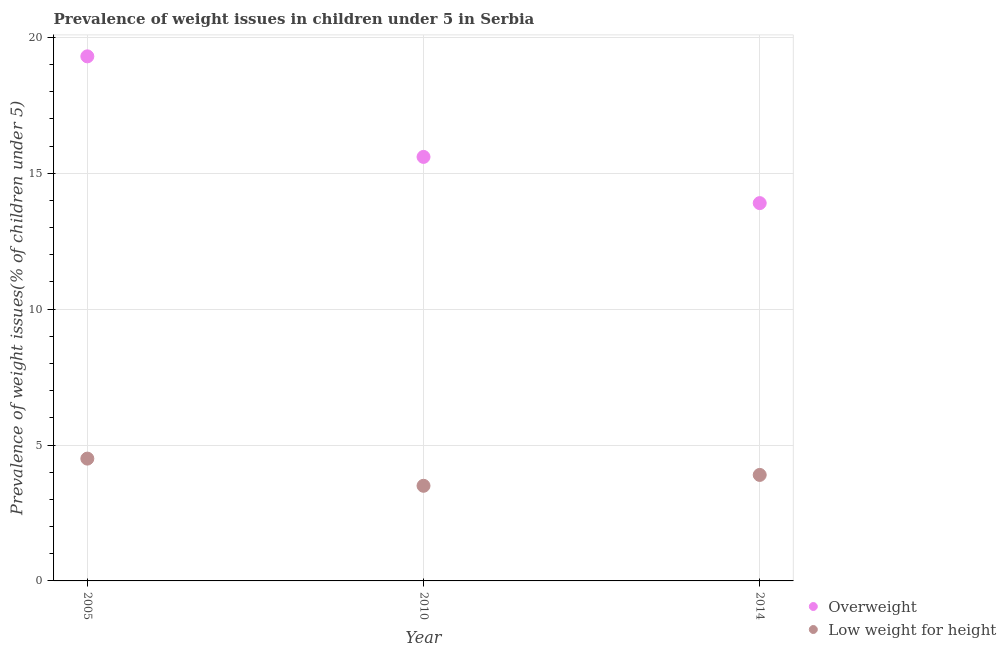How many different coloured dotlines are there?
Offer a terse response. 2. Is the number of dotlines equal to the number of legend labels?
Provide a short and direct response. Yes. Across all years, what is the maximum percentage of overweight children?
Offer a terse response. 19.3. In which year was the percentage of underweight children maximum?
Your answer should be very brief. 2005. What is the total percentage of underweight children in the graph?
Your answer should be compact. 11.9. What is the difference between the percentage of overweight children in 2005 and that in 2014?
Give a very brief answer. 5.4. What is the difference between the percentage of overweight children in 2010 and the percentage of underweight children in 2014?
Offer a very short reply. 11.7. What is the average percentage of underweight children per year?
Offer a terse response. 3.97. In the year 2010, what is the difference between the percentage of overweight children and percentage of underweight children?
Provide a short and direct response. 12.1. In how many years, is the percentage of overweight children greater than 9 %?
Offer a terse response. 3. What is the ratio of the percentage of overweight children in 2005 to that in 2014?
Make the answer very short. 1.39. Is the difference between the percentage of underweight children in 2005 and 2010 greater than the difference between the percentage of overweight children in 2005 and 2010?
Offer a very short reply. No. What is the difference between the highest and the second highest percentage of underweight children?
Provide a short and direct response. 0.6. Does the percentage of underweight children monotonically increase over the years?
Provide a succinct answer. No. Is the percentage of underweight children strictly greater than the percentage of overweight children over the years?
Your answer should be very brief. No. How many dotlines are there?
Keep it short and to the point. 2. How many years are there in the graph?
Ensure brevity in your answer.  3. Are the values on the major ticks of Y-axis written in scientific E-notation?
Keep it short and to the point. No. Does the graph contain any zero values?
Your answer should be compact. No. Where does the legend appear in the graph?
Your response must be concise. Bottom right. What is the title of the graph?
Ensure brevity in your answer.  Prevalence of weight issues in children under 5 in Serbia. What is the label or title of the Y-axis?
Keep it short and to the point. Prevalence of weight issues(% of children under 5). What is the Prevalence of weight issues(% of children under 5) in Overweight in 2005?
Offer a terse response. 19.3. What is the Prevalence of weight issues(% of children under 5) of Low weight for height in 2005?
Offer a very short reply. 4.5. What is the Prevalence of weight issues(% of children under 5) in Overweight in 2010?
Offer a terse response. 15.6. What is the Prevalence of weight issues(% of children under 5) of Overweight in 2014?
Give a very brief answer. 13.9. What is the Prevalence of weight issues(% of children under 5) in Low weight for height in 2014?
Make the answer very short. 3.9. Across all years, what is the maximum Prevalence of weight issues(% of children under 5) in Overweight?
Make the answer very short. 19.3. Across all years, what is the maximum Prevalence of weight issues(% of children under 5) in Low weight for height?
Provide a short and direct response. 4.5. Across all years, what is the minimum Prevalence of weight issues(% of children under 5) in Overweight?
Offer a terse response. 13.9. What is the total Prevalence of weight issues(% of children under 5) in Overweight in the graph?
Ensure brevity in your answer.  48.8. What is the total Prevalence of weight issues(% of children under 5) of Low weight for height in the graph?
Provide a succinct answer. 11.9. What is the difference between the Prevalence of weight issues(% of children under 5) of Overweight in 2005 and that in 2010?
Ensure brevity in your answer.  3.7. What is the difference between the Prevalence of weight issues(% of children under 5) in Low weight for height in 2005 and that in 2010?
Keep it short and to the point. 1. What is the difference between the Prevalence of weight issues(% of children under 5) in Low weight for height in 2005 and that in 2014?
Your answer should be very brief. 0.6. What is the difference between the Prevalence of weight issues(% of children under 5) of Overweight in 2010 and that in 2014?
Offer a terse response. 1.7. What is the difference between the Prevalence of weight issues(% of children under 5) in Low weight for height in 2010 and that in 2014?
Give a very brief answer. -0.4. What is the difference between the Prevalence of weight issues(% of children under 5) of Overweight in 2005 and the Prevalence of weight issues(% of children under 5) of Low weight for height in 2014?
Provide a short and direct response. 15.4. What is the average Prevalence of weight issues(% of children under 5) of Overweight per year?
Your answer should be very brief. 16.27. What is the average Prevalence of weight issues(% of children under 5) in Low weight for height per year?
Ensure brevity in your answer.  3.97. In the year 2005, what is the difference between the Prevalence of weight issues(% of children under 5) in Overweight and Prevalence of weight issues(% of children under 5) in Low weight for height?
Keep it short and to the point. 14.8. In the year 2014, what is the difference between the Prevalence of weight issues(% of children under 5) in Overweight and Prevalence of weight issues(% of children under 5) in Low weight for height?
Your response must be concise. 10. What is the ratio of the Prevalence of weight issues(% of children under 5) in Overweight in 2005 to that in 2010?
Provide a short and direct response. 1.24. What is the ratio of the Prevalence of weight issues(% of children under 5) in Low weight for height in 2005 to that in 2010?
Provide a succinct answer. 1.29. What is the ratio of the Prevalence of weight issues(% of children under 5) of Overweight in 2005 to that in 2014?
Provide a short and direct response. 1.39. What is the ratio of the Prevalence of weight issues(% of children under 5) of Low weight for height in 2005 to that in 2014?
Offer a very short reply. 1.15. What is the ratio of the Prevalence of weight issues(% of children under 5) in Overweight in 2010 to that in 2014?
Your answer should be very brief. 1.12. What is the ratio of the Prevalence of weight issues(% of children under 5) of Low weight for height in 2010 to that in 2014?
Give a very brief answer. 0.9. What is the difference between the highest and the second highest Prevalence of weight issues(% of children under 5) of Low weight for height?
Offer a very short reply. 0.6. What is the difference between the highest and the lowest Prevalence of weight issues(% of children under 5) of Overweight?
Ensure brevity in your answer.  5.4. What is the difference between the highest and the lowest Prevalence of weight issues(% of children under 5) of Low weight for height?
Provide a short and direct response. 1. 